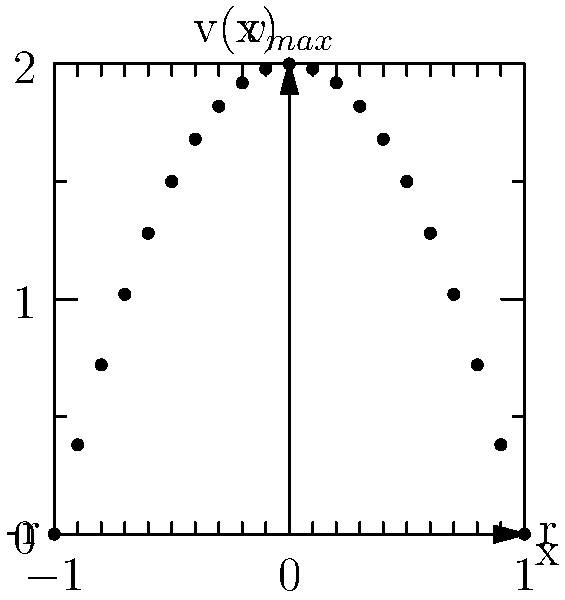In the velocity profile shown for laminar flow through a circular pipe, what is the mathematical expression for the velocity $v(x)$ as a function of the radial position $x$, given that the maximum velocity $v_{max}$ occurs at the center of the pipe (x = 0) and the pipe radius is $r$? To determine the mathematical expression for the velocity profile, we can follow these steps:

1) Observe that the velocity profile is parabolic, with the maximum velocity at the center (x = 0) and zero velocity at the pipe walls (x = ±r).

2) The general form of a parabolic equation is:
   $v(x) = a(x^2 - b)$

3) We know that at x = 0, v = $v_{max}$. This gives us:
   $v_{max} = a(0^2 - b) = -ab$

4) At x = r (pipe wall), v = 0:
   $0 = a(r^2 - b)$
   $b = r^2$

5) Substituting this back into the equation from step 3:
   $v_{max} = -ar^2$
   $a = -\frac{v_{max}}{r^2}$

6) Now we can write our full equation:
   $v(x) = -\frac{v_{max}}{r^2}(x^2 - r^2)$

7) Rearranging:
   $v(x) = v_{max}(1 - \frac{x^2}{r^2})$

This is the standard form of the velocity profile equation for laminar flow in a circular pipe.
Answer: $v(x) = v_{max}(1 - \frac{x^2}{r^2})$ 